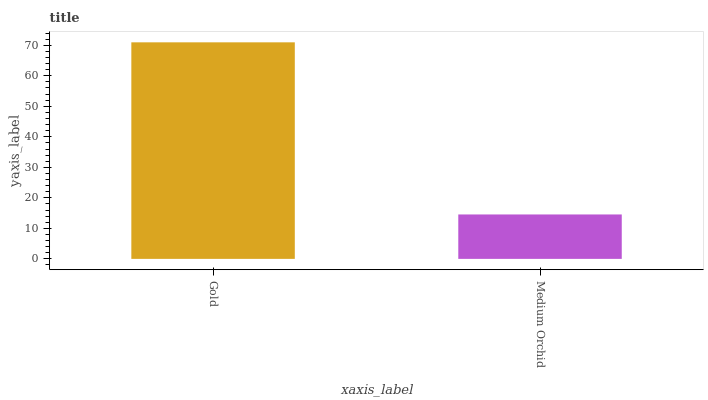Is Medium Orchid the minimum?
Answer yes or no. Yes. Is Gold the maximum?
Answer yes or no. Yes. Is Medium Orchid the maximum?
Answer yes or no. No. Is Gold greater than Medium Orchid?
Answer yes or no. Yes. Is Medium Orchid less than Gold?
Answer yes or no. Yes. Is Medium Orchid greater than Gold?
Answer yes or no. No. Is Gold less than Medium Orchid?
Answer yes or no. No. Is Gold the high median?
Answer yes or no. Yes. Is Medium Orchid the low median?
Answer yes or no. Yes. Is Medium Orchid the high median?
Answer yes or no. No. Is Gold the low median?
Answer yes or no. No. 